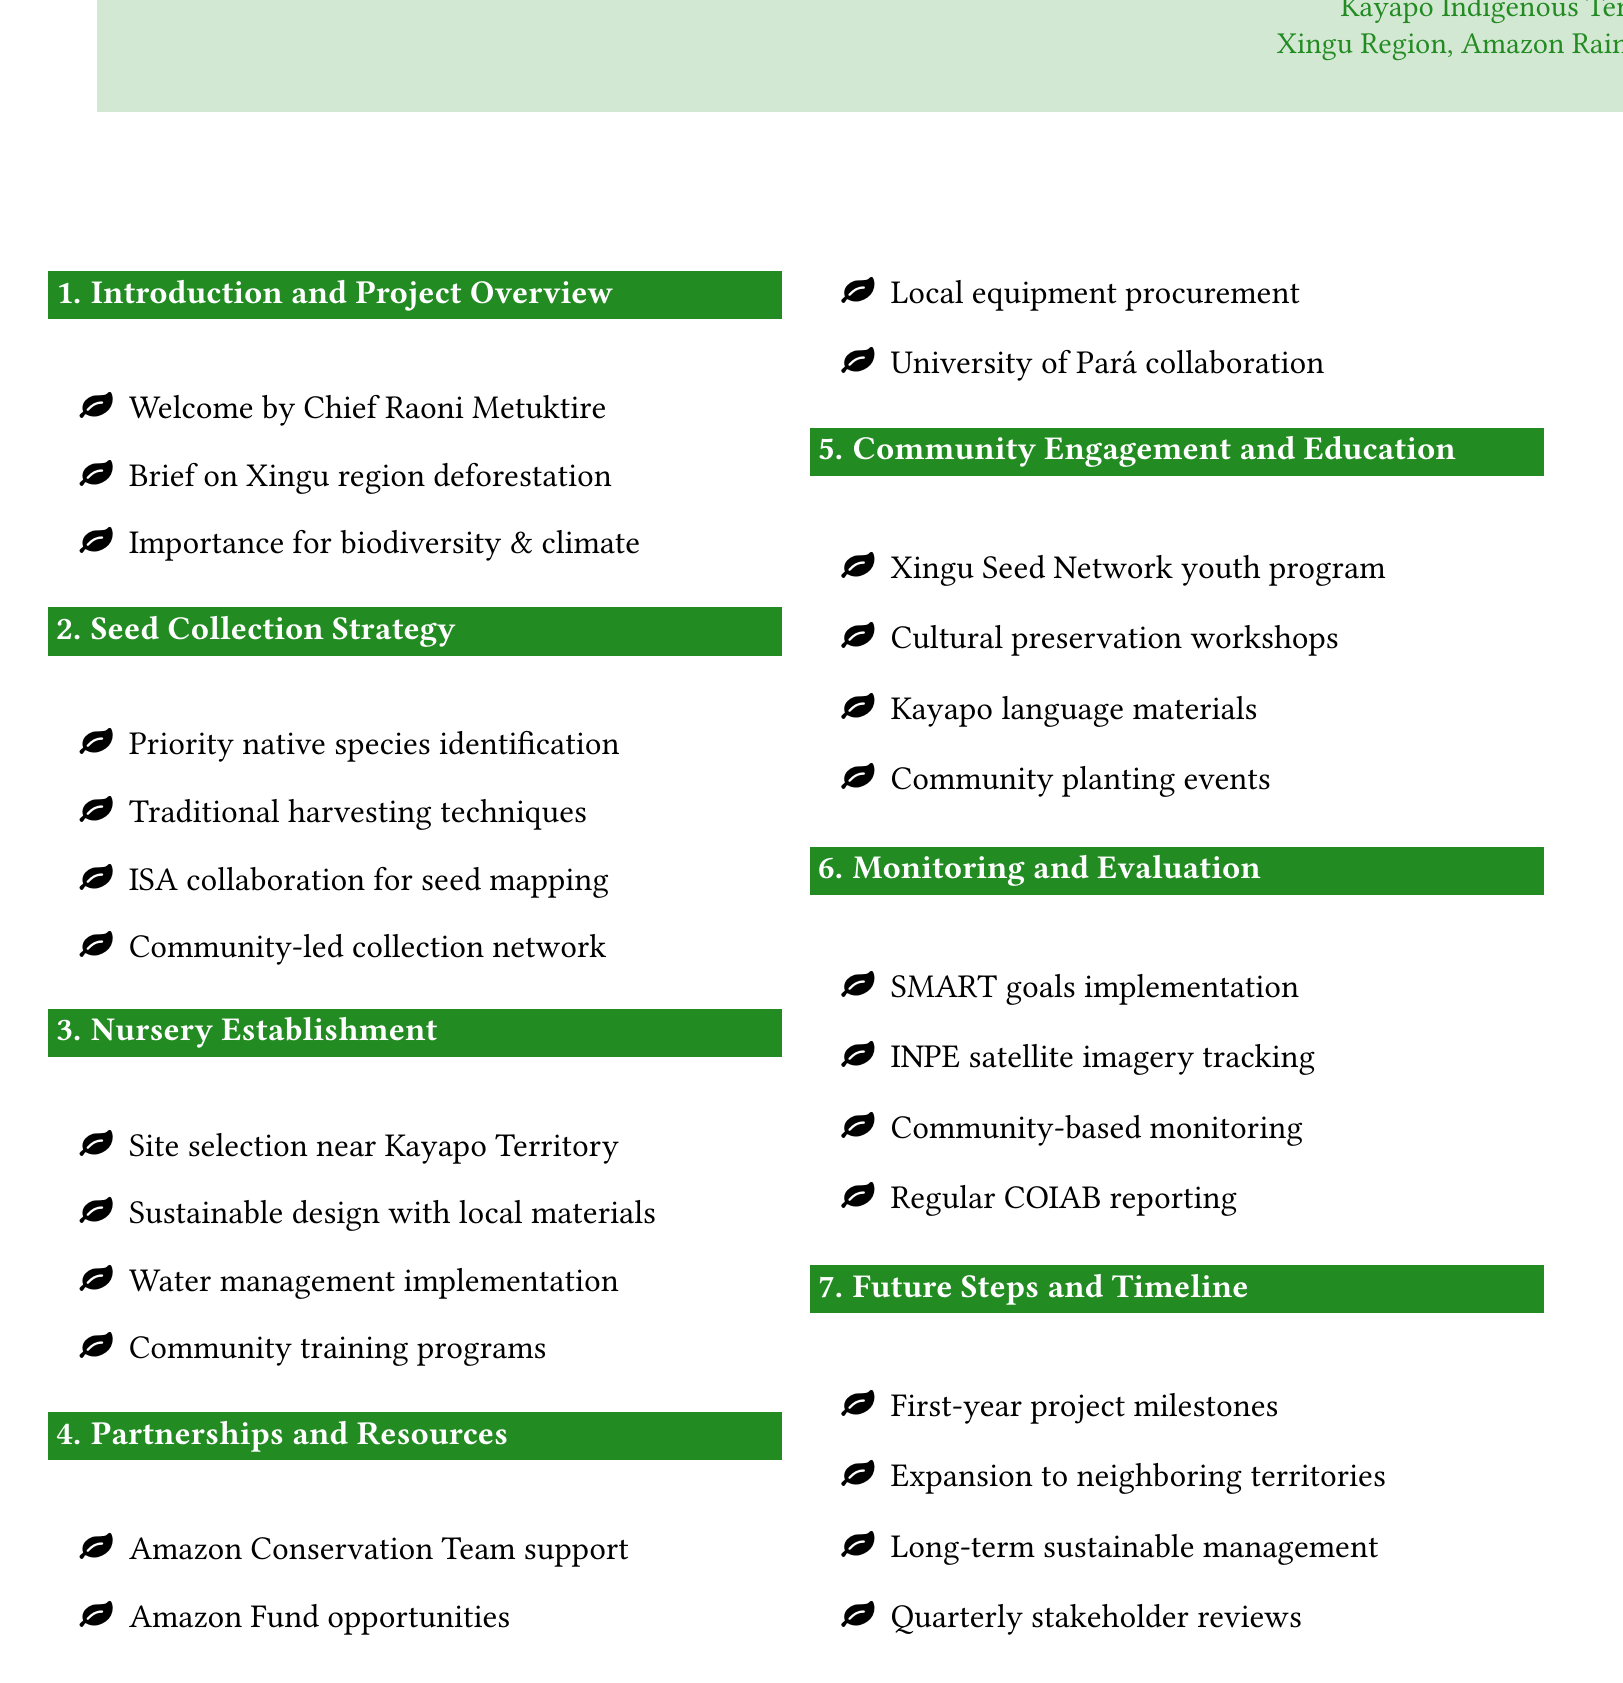What is the title of the agenda? The title is prominently displayed at the top of the document, noting the focus on reforestation projects.
Answer: Reforestation Project Planning Who welcomes participants at the session? The welcome is specifically attributed to Chief Raoni Metuktire, indicating his role in the project.
Answer: Chief Raoni Metuktire What native species are prioritized for seed collection? Specific examples of native species are listed under the seed collection strategy section.
Answer: Brazil nut, açaí palm, ipê trees Which organization collaborates for seed mapping? The document notes a collaborative effort with a specific organization for seed mapping activities.
Answer: Instituto Socioambiental (ISA) What training is provided to community members in nursery establishment? The nursery establishment section outlines a specific type of training provided to enhance community skills.
Answer: Nursery management What type of goals will be implemented for monitoring? The section on monitoring and evaluation describes a structured approach to setting goals for the project.
Answer: SMART What is planned for community engagement through youth? The agenda mentions a specific program aimed at involving youth in the reforestation efforts.
Answer: Xingu Seed Network program How often will stakeholder review meetings be scheduled? The future steps and timeline section specifies the frequency of review meetings.
Answer: Quarterly 